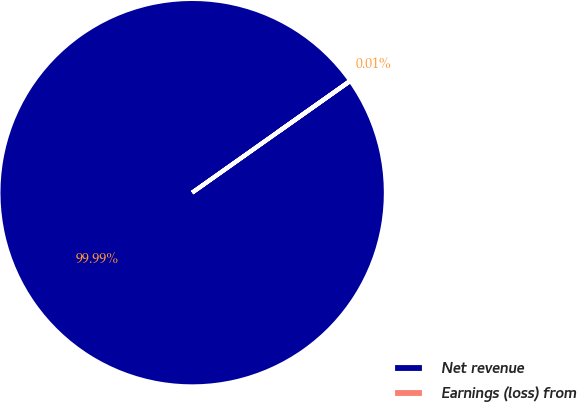Convert chart. <chart><loc_0><loc_0><loc_500><loc_500><pie_chart><fcel>Net revenue<fcel>Earnings (loss) from<nl><fcel>99.99%<fcel>0.01%<nl></chart> 